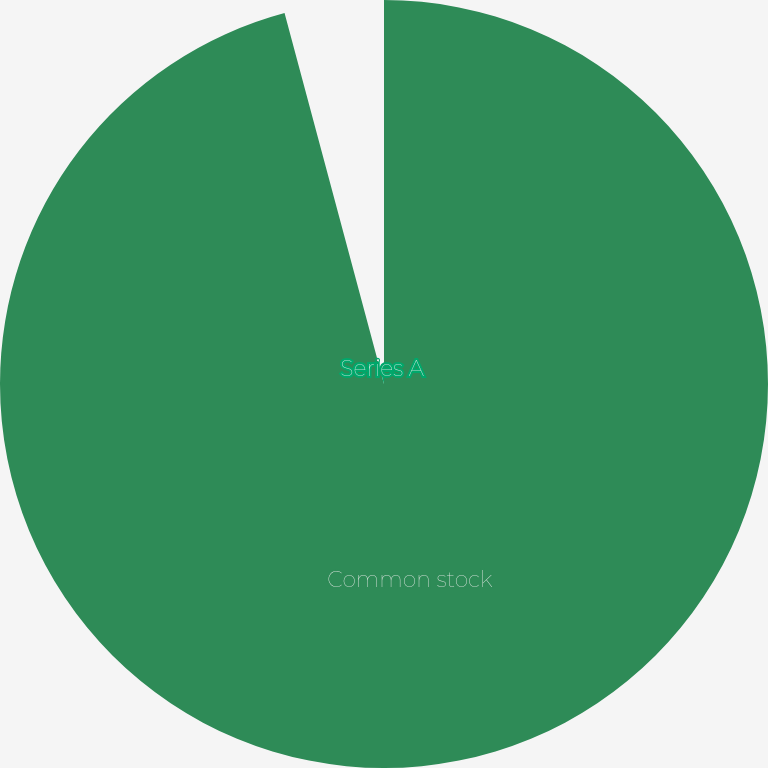<chart> <loc_0><loc_0><loc_500><loc_500><pie_chart><fcel>Common stock<fcel>Series A<nl><fcel>95.83%<fcel>4.17%<nl></chart> 